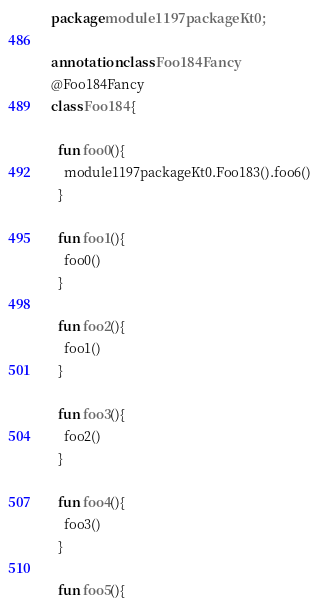Convert code to text. <code><loc_0><loc_0><loc_500><loc_500><_Kotlin_>package module1197packageKt0;

annotation class Foo184Fancy
@Foo184Fancy
class Foo184 {

  fun foo0(){
    module1197packageKt0.Foo183().foo6()
  }

  fun foo1(){
    foo0()
  }

  fun foo2(){
    foo1()
  }

  fun foo3(){
    foo2()
  }

  fun foo4(){
    foo3()
  }

  fun foo5(){</code> 